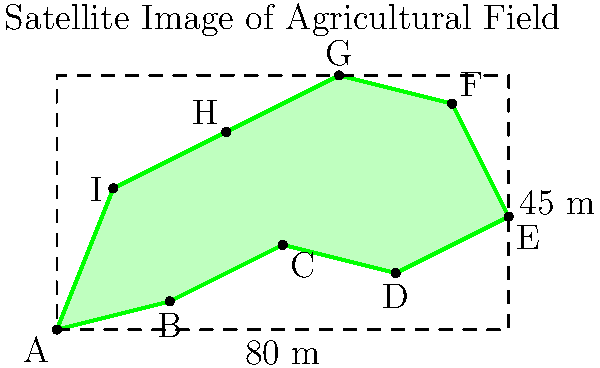A farmer in Bozalan, Cizre wants to estimate the area of his irregularly shaped agricultural field using a satellite image. The field is enclosed within a rectangle measuring 80 meters by 45 meters. If the actual area of the field is approximately 75% of the rectangle's area, what is the estimated area of the agricultural field in square meters? To solve this problem, we'll follow these steps:

1. Calculate the area of the rectangle:
   $A_{rectangle} = length \times width$
   $A_{rectangle} = 80 \text{ m} \times 45 \text{ m} = 3600 \text{ m}^2$

2. Calculate 75% of the rectangle's area:
   $A_{field} = 75\% \times A_{rectangle}$
   $A_{field} = 0.75 \times 3600 \text{ m}^2$
   $A_{field} = 2700 \text{ m}^2$

Therefore, the estimated area of the agricultural field is 2700 square meters.

This method of estimation is useful when dealing with irregularly shaped fields, as it provides a quick approximation without the need for complex calculations. It's particularly relevant in regions like Bozalan, Cizre, where agricultural land may have irregular boundaries due to topography or historical land division practices.
Answer: 2700 m² 